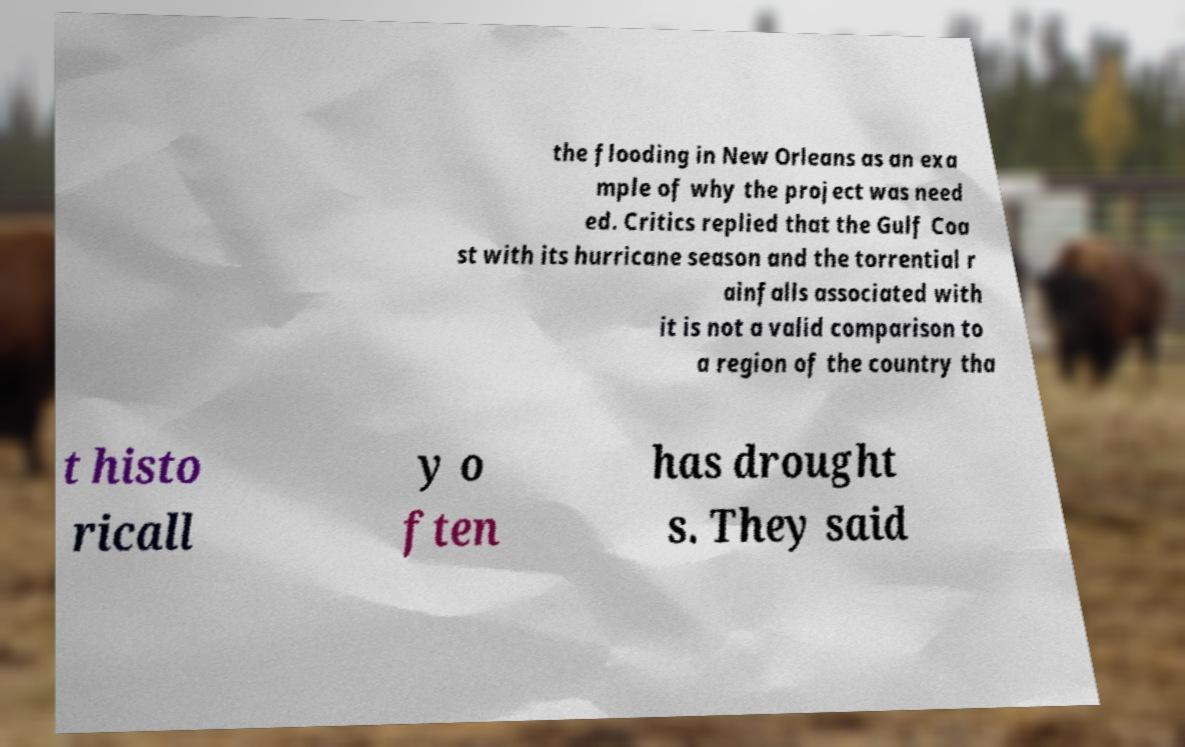There's text embedded in this image that I need extracted. Can you transcribe it verbatim? the flooding in New Orleans as an exa mple of why the project was need ed. Critics replied that the Gulf Coa st with its hurricane season and the torrential r ainfalls associated with it is not a valid comparison to a region of the country tha t histo ricall y o ften has drought s. They said 